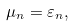<formula> <loc_0><loc_0><loc_500><loc_500>\mu _ { n } = \varepsilon _ { n } ,</formula> 